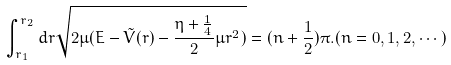<formula> <loc_0><loc_0><loc_500><loc_500>\int _ { r _ { 1 } } ^ { r _ { 2 } } d r \sqrt { 2 \mu ( E - \tilde { V } ( r ) - \frac { \eta + \frac { 1 } { 4 } } 2 \mu r ^ { 2 } ) } = ( n + \frac { 1 } { 2 } ) \pi . ( n = 0 , 1 , 2 , \cdots )</formula> 